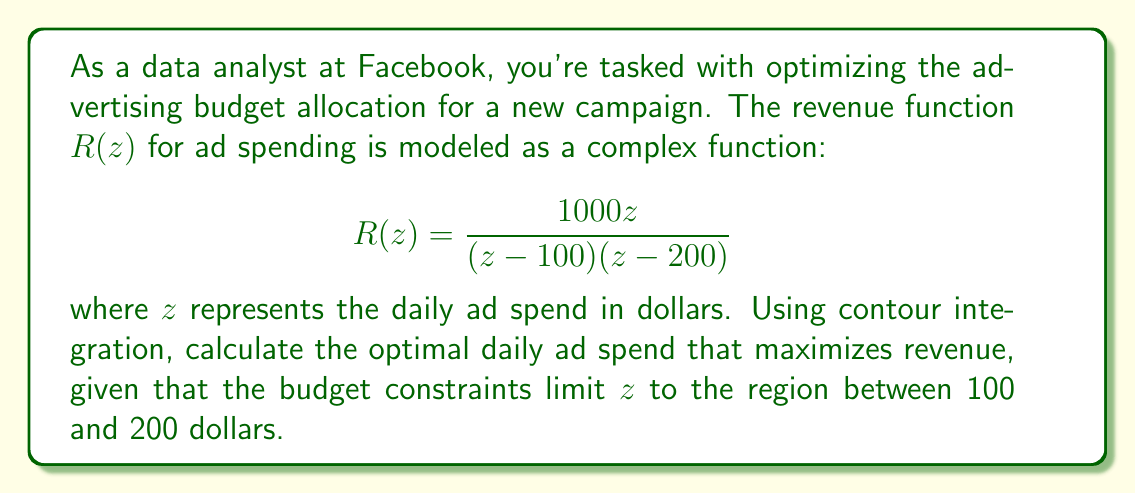Solve this math problem. To solve this problem, we'll use the residue theorem from complex analysis. The optimal ad spend will be where the function $R(z)$ has its maximum value on the real axis between 100 and 200.

1) First, we need to find the residues of $R(z)$ at its poles. The poles are at $z=100$ and $z=200$.

2) For $z=100$:
   $$\text{Res}(R, 100) = \lim_{z \to 100} (z-100)R(z) = \lim_{z \to 100} \frac{1000z}{z-200} = -1000$$

3) For $z=200$:
   $$\text{Res}(R, 200) = \lim_{z \to 200} (z-200)R(z) = \lim_{z \to 200} \frac{1000z}{z-100} = 2000$$

4) The sum of residues is $-1000 + 2000 = 1000$.

5) Now, we can use the residue theorem. Let $C$ be a semicircular contour in the upper half-plane, with diameter along the real axis from 100 to 200. Then:

   $$\int_C R(z)dz = 2\pi i \cdot 1000 = 2000\pi i$$

6) As the radius of the semicircle approaches infinity, the integral along the arc approaches zero, so the integral along the real axis from 100 to 200 is approximately $2000\pi i$.

7) The imaginary part of this integral represents the difference in the real part of $R(z)$ between the endpoints. Since this difference is positive, the maximum of $R(z)$ occurs at the right endpoint, $z=200$.

Therefore, the optimal daily ad spend is $200.
Answer: The optimal daily ad spend to maximize revenue is $200. 